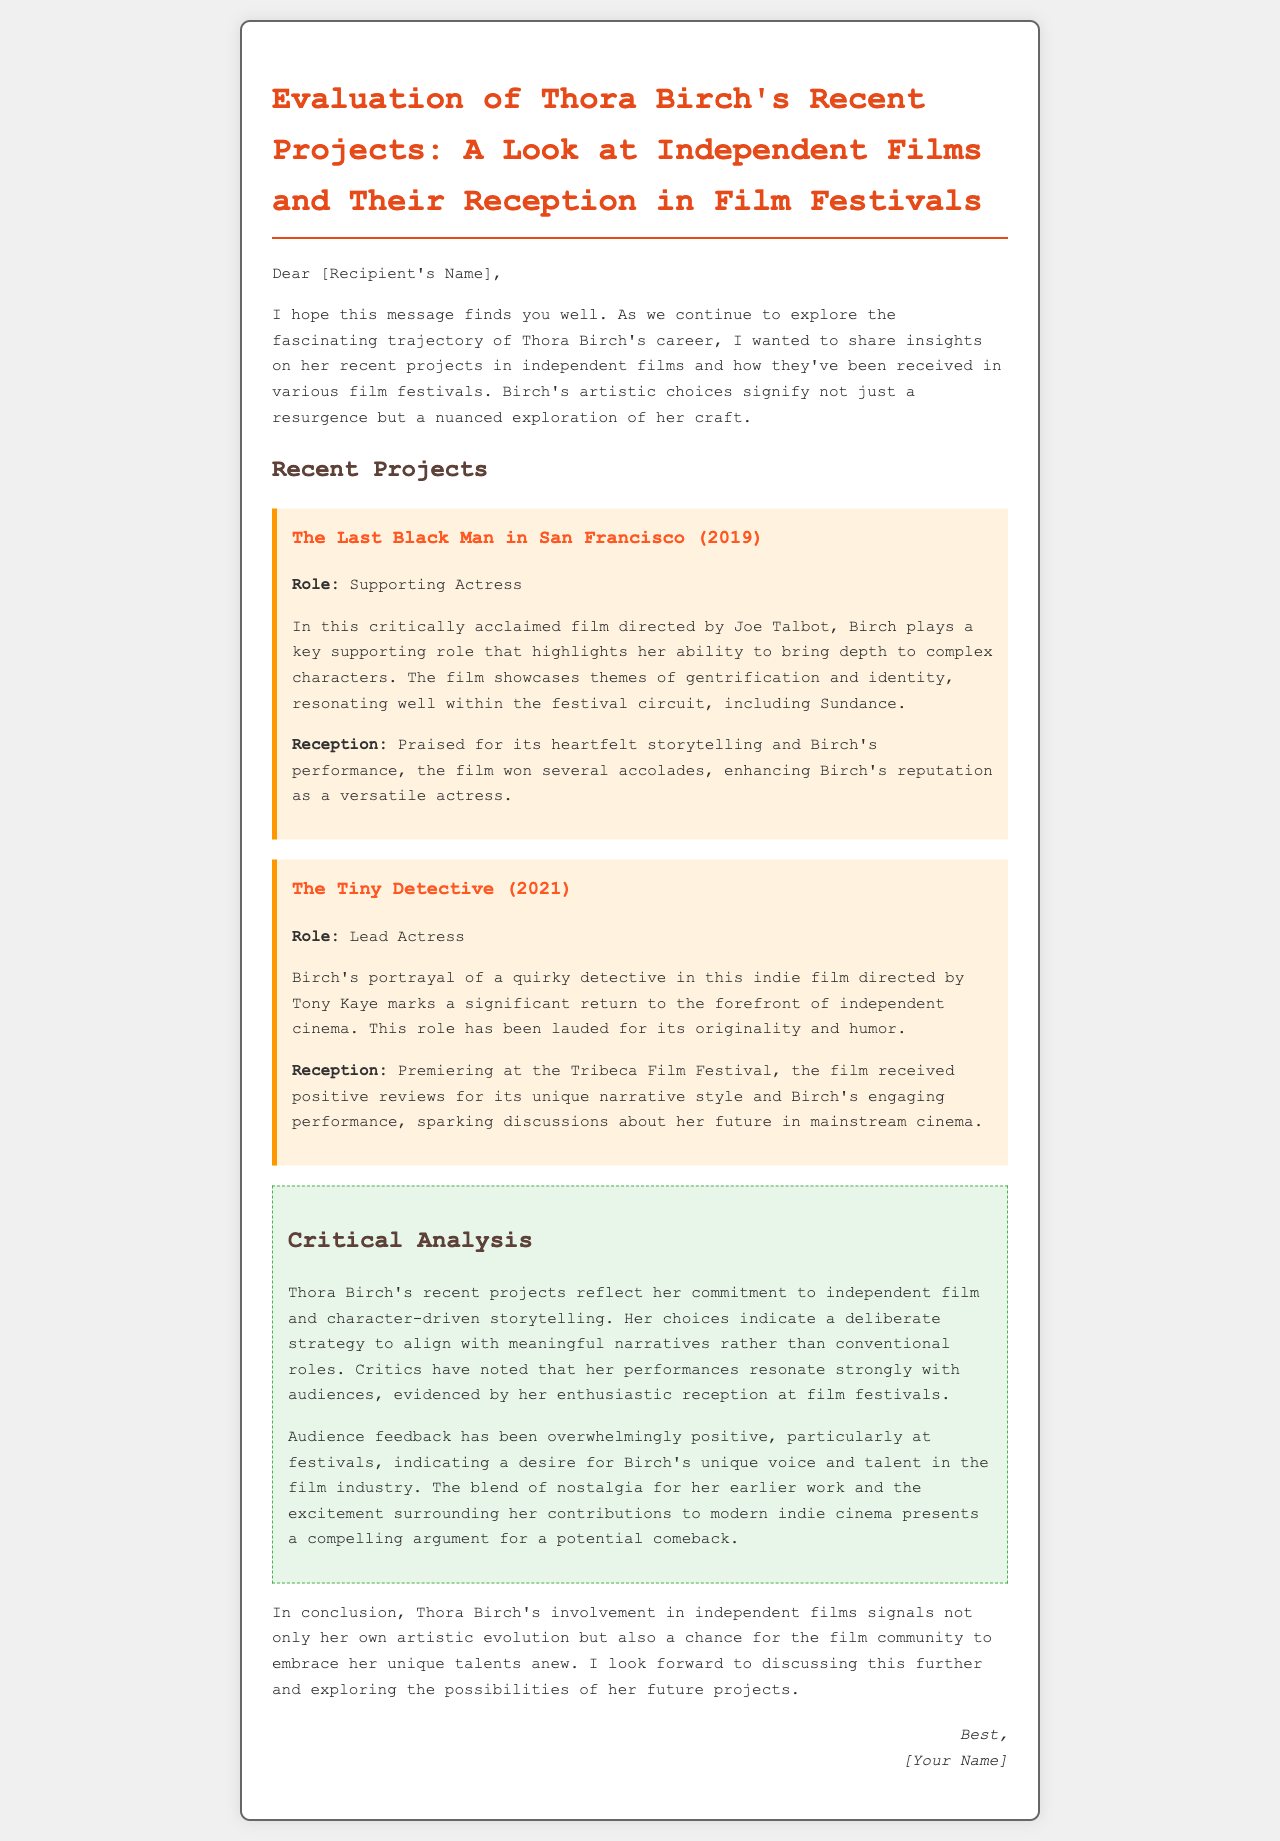What is the title of Thora Birch's 2019 project? The title of the project is mentioned as "The Last Black Man in San Francisco."
Answer: The Last Black Man in San Francisco What role did Thora Birch play in "The Tiny Detective"? The document specifies that Birch played the role of Lead Actress in this film.
Answer: Lead Actress Which film festival did "The Tiny Detective" premiere at? The document states that it premiered at the Tribeca Film Festival.
Answer: Tribeca Film Festival What theme does "The Last Black Man in San Francisco" address? The email highlights that the film showcases themes of gentrification and identity.
Answer: Gentrification and identity How did the audiences react to Thora Birch's recent performances? The document notes that audience feedback has been overwhelmingly positive.
Answer: Overwhelmingly positive What year was "The Tiny Detective" released? The year of release for "The Tiny Detective" is listed as 2021 in the document.
Answer: 2021 In what way does the document describe Thora Birch's career trajectory? The email mentions that it signifies not just a resurgence but a nuanced exploration of her craft.
Answer: A nuanced exploration What is indicated about Thora Birch's strategy in choosing projects? The email states she aligns with meaningful narratives rather than conventional roles.
Answer: Meaningful narratives What does the email conclude about Thora Birch's involvement in independent films? It suggests that her involvement signals her artistic evolution and a chance to embrace her talents anew.
Answer: Artistic evolution and embrace of talents 